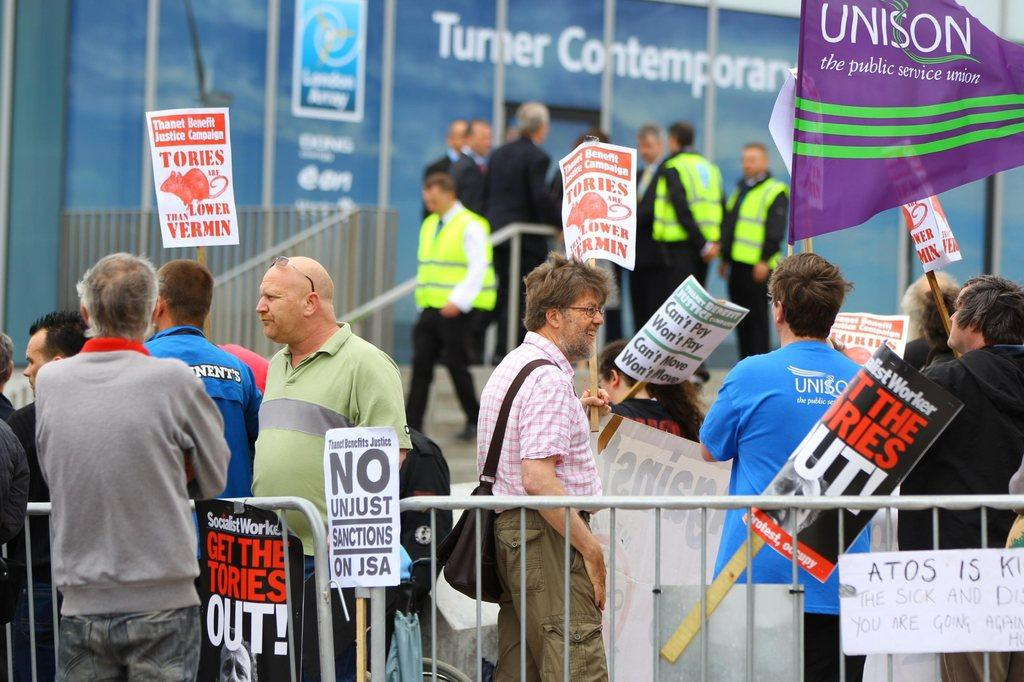What are the people in the center of the image doing? The people in the center of the image are standing and holding boards. What can be seen at the bottom of the image? There is a fence at the bottom of the image. What is visible in the background of the image? There is a board, flags, stairs, and people in the background of the image. How does the dust settle on the wing in the image? There is no dust or wing present in the image. In which direction are the people walking in the image? The image does not show people walking; they are standing and holding boards. 